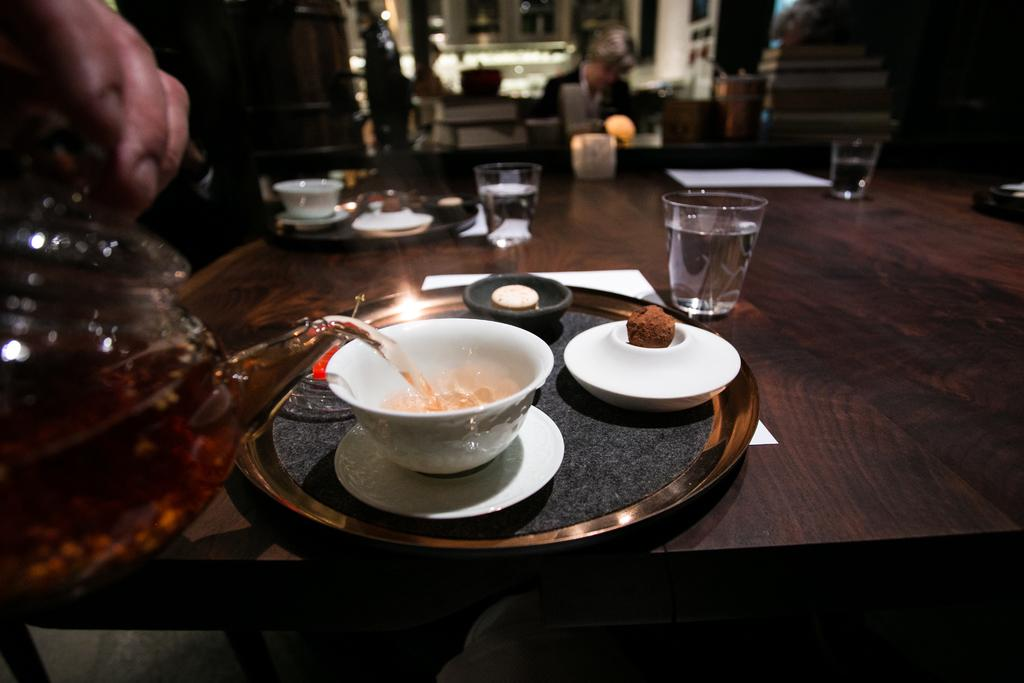What is on the table in the image? There is a plate on the table. What items are on the plate? There is a bowl, a saucer, a glass, and a paper on the plate. What is the person doing in the image? The person is pouring a drink into the bowl. What type of prose is being written on the paper in the image? There is no prose visible on the paper in the image. Can you see a boot on the table in the image? There is no boot present in the image. 